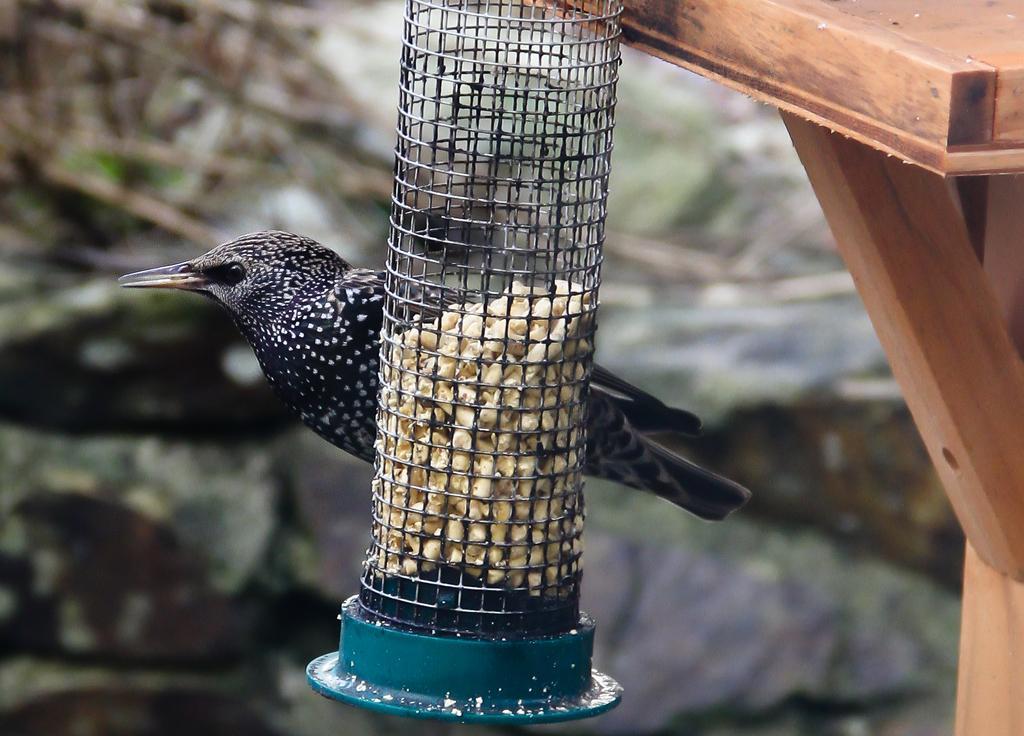How would you summarize this image in a sentence or two? In front of the picture, we see a steel mesh bottle containing the grains. Behind that, we see a bird in black color. It has a long beak. On the right side, we see a wooden object. There are trees in the background. This picture is blurred in the background. 